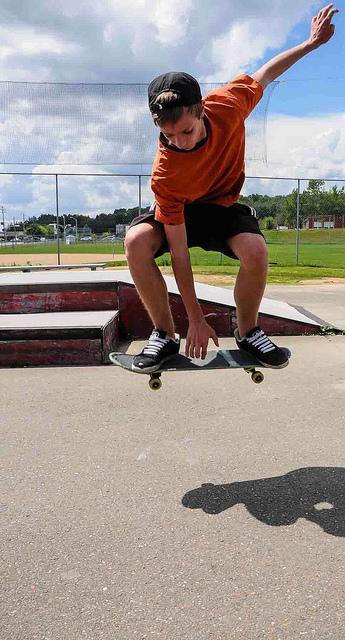How many skateboards are there?
Give a very brief answer. 1. How many motorcycles are between the sidewalk and the yellow line in the road?
Give a very brief answer. 0. 